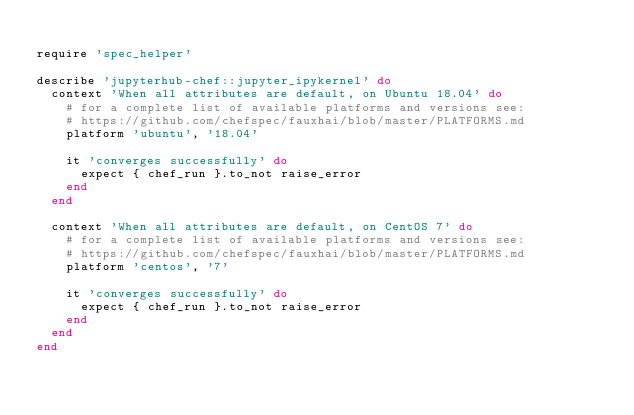Convert code to text. <code><loc_0><loc_0><loc_500><loc_500><_Ruby_>
require 'spec_helper'

describe 'jupyterhub-chef::jupyter_ipykernel' do
  context 'When all attributes are default, on Ubuntu 18.04' do
    # for a complete list of available platforms and versions see:
    # https://github.com/chefspec/fauxhai/blob/master/PLATFORMS.md
    platform 'ubuntu', '18.04'

    it 'converges successfully' do
      expect { chef_run }.to_not raise_error
    end
  end

  context 'When all attributes are default, on CentOS 7' do
    # for a complete list of available platforms and versions see:
    # https://github.com/chefspec/fauxhai/blob/master/PLATFORMS.md
    platform 'centos', '7'

    it 'converges successfully' do
      expect { chef_run }.to_not raise_error
    end
  end
end
</code> 